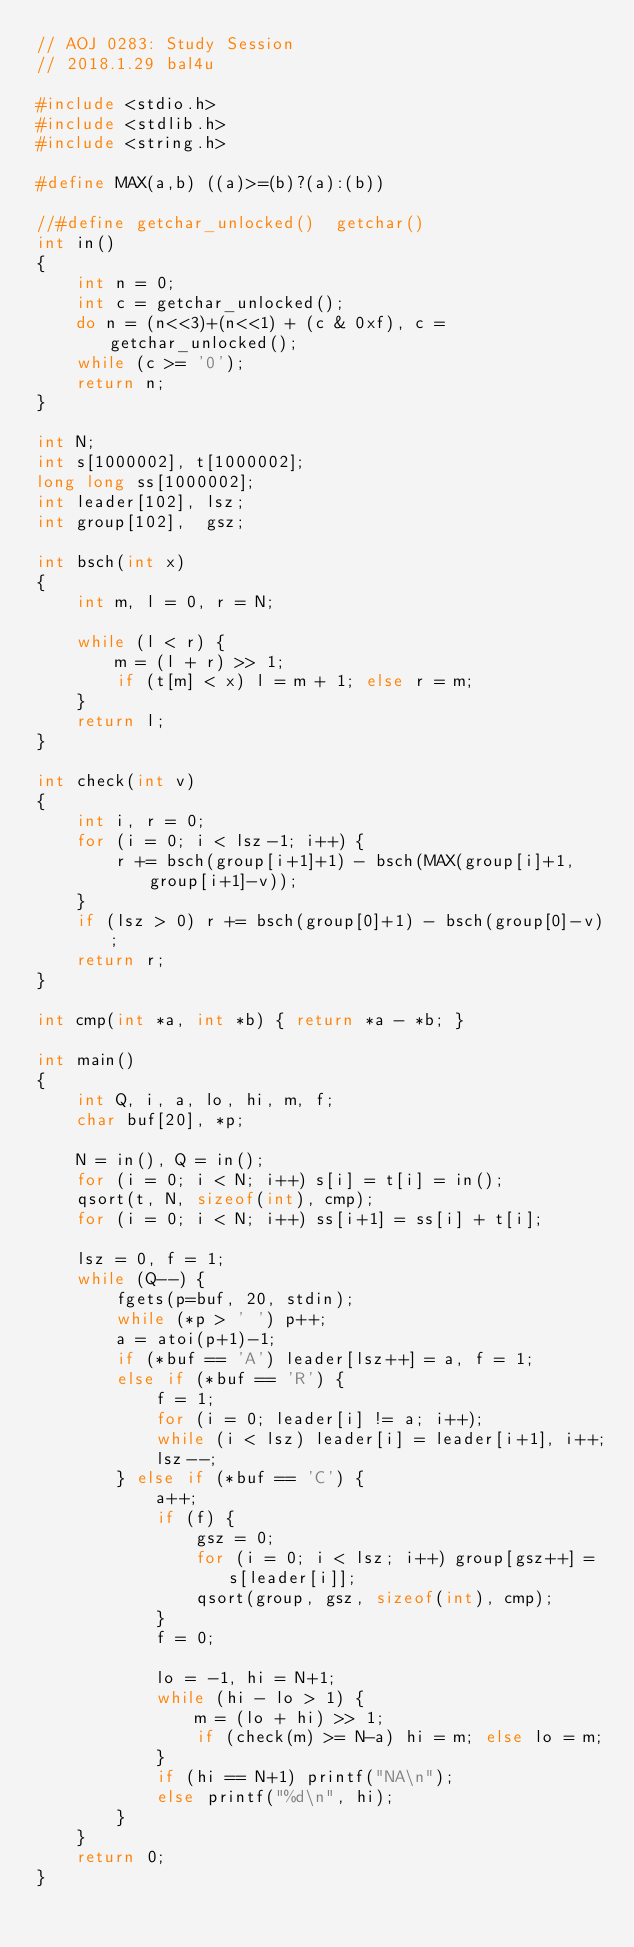Convert code to text. <code><loc_0><loc_0><loc_500><loc_500><_C_>// AOJ 0283: Study Session
// 2018.1.29 bal4u

#include <stdio.h>
#include <stdlib.h>
#include <string.h>

#define MAX(a,b) ((a)>=(b)?(a):(b))

//#define getchar_unlocked()  getchar()
int in()
{
	int n = 0;
	int c = getchar_unlocked();
	do n = (n<<3)+(n<<1) + (c & 0xf), c = getchar_unlocked();
	while (c >= '0');
	return n;
}

int N;
int s[1000002], t[1000002];
long long ss[1000002];
int leader[102], lsz;
int group[102],  gsz;

int bsch(int x)
{
	int m, l = 0, r = N;

    while (l < r) {
        m = (l + r) >> 1;
        if (t[m] < x) l = m + 1; else r = m;
    }
	return l;
}

int check(int v)
{
	int i, r = 0;
    for (i = 0; i < lsz-1; i++) {
		r += bsch(group[i+1]+1) - bsch(MAX(group[i]+1, group[i+1]-v));
	}
	if (lsz > 0) r += bsch(group[0]+1) - bsch(group[0]-v);
	return r;
}

int cmp(int *a, int *b) { return *a - *b; }

int main()
{
	int Q, i, a, lo, hi, m, f;
	char buf[20], *p;
	
	N = in(), Q = in();
    for (i = 0; i < N; i++) s[i] = t[i] = in();
	qsort(t, N, sizeof(int), cmp);
	for (i = 0; i < N; i++) ss[i+1] = ss[i] + t[i];

	lsz = 0, f = 1;
    while (Q--) {
		fgets(p=buf, 20, stdin);
		while (*p > ' ') p++;
		a = atoi(p+1)-1;
		if (*buf == 'A') leader[lsz++] = a, f = 1;
		else if (*buf == 'R') {
			f = 1;
            for (i = 0; leader[i] != a; i++);
			while (i < lsz) leader[i] = leader[i+1], i++;
			lsz--;
        } else if (*buf == 'C') {
			a++;
			if (f) {
				gsz = 0;
				for (i = 0; i < lsz; i++) group[gsz++] = s[leader[i]];
				qsort(group, gsz, sizeof(int), cmp);
			}
			f = 0;

			lo = -1, hi = N+1;
            while (hi - lo > 1) {
                m = (lo + hi) >> 1;
                if (check(m) >= N-a) hi = m; else lo = m;
            }
            if (hi == N+1) printf("NA\n");
            else printf("%d\n", hi);
        }
    }
    return 0;
}
</code> 